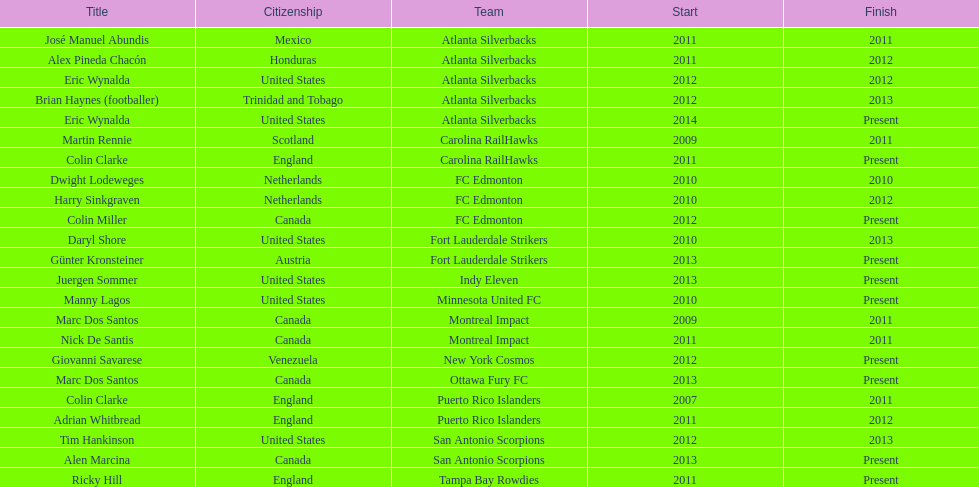Would you be able to parse every entry in this table? {'header': ['Title', 'Citizenship', 'Team', 'Start', 'Finish'], 'rows': [['José Manuel Abundis', 'Mexico', 'Atlanta Silverbacks', '2011', '2011'], ['Alex Pineda Chacón', 'Honduras', 'Atlanta Silverbacks', '2011', '2012'], ['Eric Wynalda', 'United States', 'Atlanta Silverbacks', '2012', '2012'], ['Brian Haynes (footballer)', 'Trinidad and Tobago', 'Atlanta Silverbacks', '2012', '2013'], ['Eric Wynalda', 'United States', 'Atlanta Silverbacks', '2014', 'Present'], ['Martin Rennie', 'Scotland', 'Carolina RailHawks', '2009', '2011'], ['Colin Clarke', 'England', 'Carolina RailHawks', '2011', 'Present'], ['Dwight Lodeweges', 'Netherlands', 'FC Edmonton', '2010', '2010'], ['Harry Sinkgraven', 'Netherlands', 'FC Edmonton', '2010', '2012'], ['Colin Miller', 'Canada', 'FC Edmonton', '2012', 'Present'], ['Daryl Shore', 'United States', 'Fort Lauderdale Strikers', '2010', '2013'], ['Günter Kronsteiner', 'Austria', 'Fort Lauderdale Strikers', '2013', 'Present'], ['Juergen Sommer', 'United States', 'Indy Eleven', '2013', 'Present'], ['Manny Lagos', 'United States', 'Minnesota United FC', '2010', 'Present'], ['Marc Dos Santos', 'Canada', 'Montreal Impact', '2009', '2011'], ['Nick De Santis', 'Canada', 'Montreal Impact', '2011', '2011'], ['Giovanni Savarese', 'Venezuela', 'New York Cosmos', '2012', 'Present'], ['Marc Dos Santos', 'Canada', 'Ottawa Fury FC', '2013', 'Present'], ['Colin Clarke', 'England', 'Puerto Rico Islanders', '2007', '2011'], ['Adrian Whitbread', 'England', 'Puerto Rico Islanders', '2011', '2012'], ['Tim Hankinson', 'United States', 'San Antonio Scorpions', '2012', '2013'], ['Alen Marcina', 'Canada', 'San Antonio Scorpions', '2013', 'Present'], ['Ricky Hill', 'England', 'Tampa Bay Rowdies', '2011', 'Present']]} Who was the coach of fc edmonton before miller? Harry Sinkgraven. 